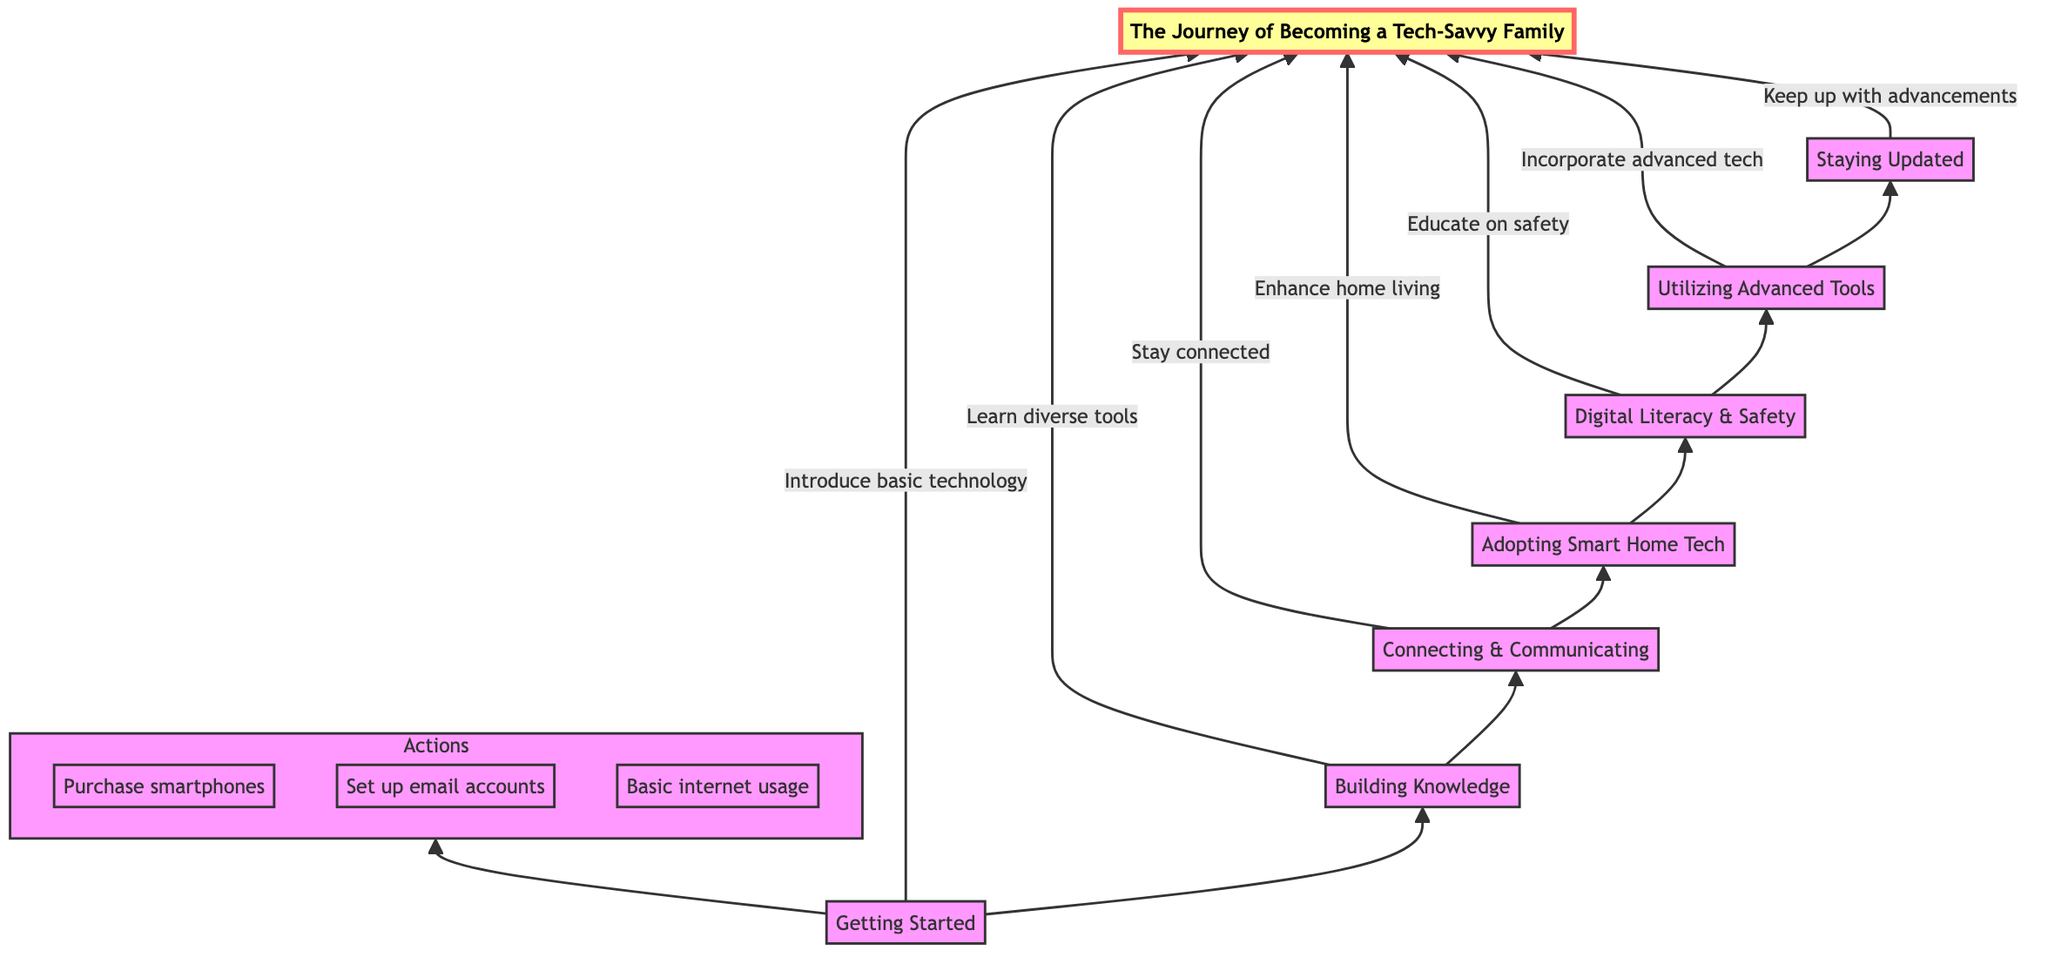What is the first step in becoming a tech-savvy family? The diagram indicates that the first step is "Getting Started." This element serves as the foundation for the journey, introducing basic technology to family members.
Answer: Getting Started How many main nodes are in the diagram? The diagram features a total of seven main nodes that represent different stages in the journey of becoming a tech-savvy family. The nodes are: Getting Started, Building Knowledge, Connecting & Communicating, Adopting Smart Home Tech, Digital Literacy & Safety, Utilizing Advanced Tools, and Staying Updated.
Answer: Seven What is the last step in the journey? According to the diagram, the last step is "Staying Updated," which focuses on keeping up with the latest technological advancements. This stage builds upon the previous knowledge and habits established in earlier steps.
Answer: Staying Updated What does the "Utilizing Advanced Tools" step incorporate? The "Utilizing Advanced Tools" step refers to the incorporation of advanced technology into daily life, such as exploring cloud storage and utilizing productivity apps. This stage builds on the previous knowledge and encourages families to take their tech-savviness further.
Answer: Advanced technology Which element focuses on educating about internet safety? The element titled "Digital Literacy & Safety" specifically emphasizes educating family members about internet safety and responsible usage. It outlines actions such as creating strong passwords and recognizing phishing emails.
Answer: Digital Literacy & Safety What is the relationship between "Building Knowledge" and "Connecting & Communicating"? "Building Knowledge" is a prerequisite for "Connecting & Communicating," as families need to learn diverse technological tools before they can use those tools effectively to stay connected with each other. This reasoning establishes a sequential flow in the diagram.
Answer: Sequential flow What actions are part of the "Getting Started" stage? The actions within the "Getting Started" stage include purchasing smartphones, setting up email accounts, and basic internet usage. These actions provide the foundational steps necessary for all subsequent activities in the journey.
Answer: Purchase smartphones, Set up email accounts, Basic internet usage 